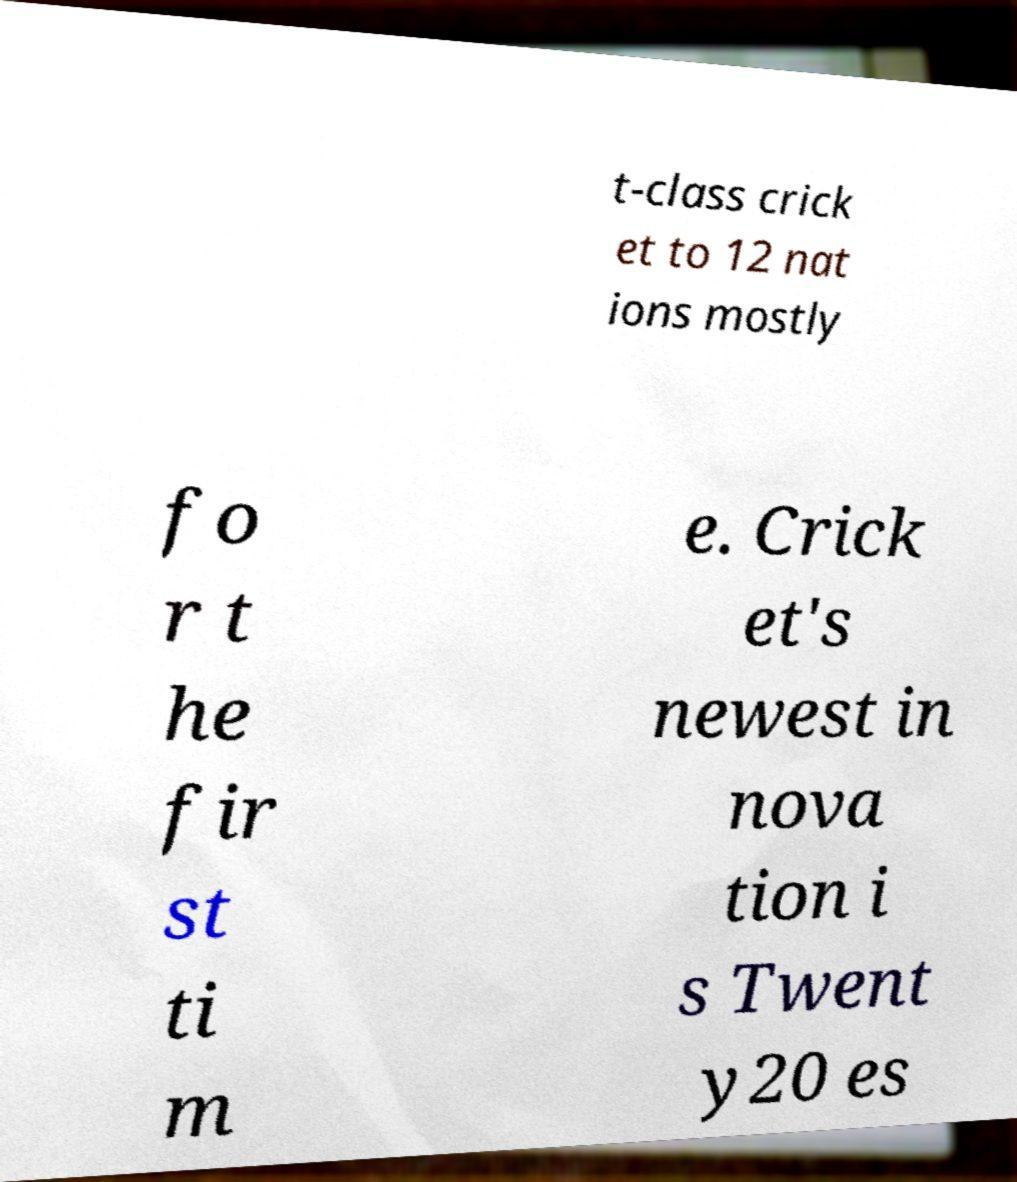Can you read and provide the text displayed in the image?This photo seems to have some interesting text. Can you extract and type it out for me? t-class crick et to 12 nat ions mostly fo r t he fir st ti m e. Crick et's newest in nova tion i s Twent y20 es 